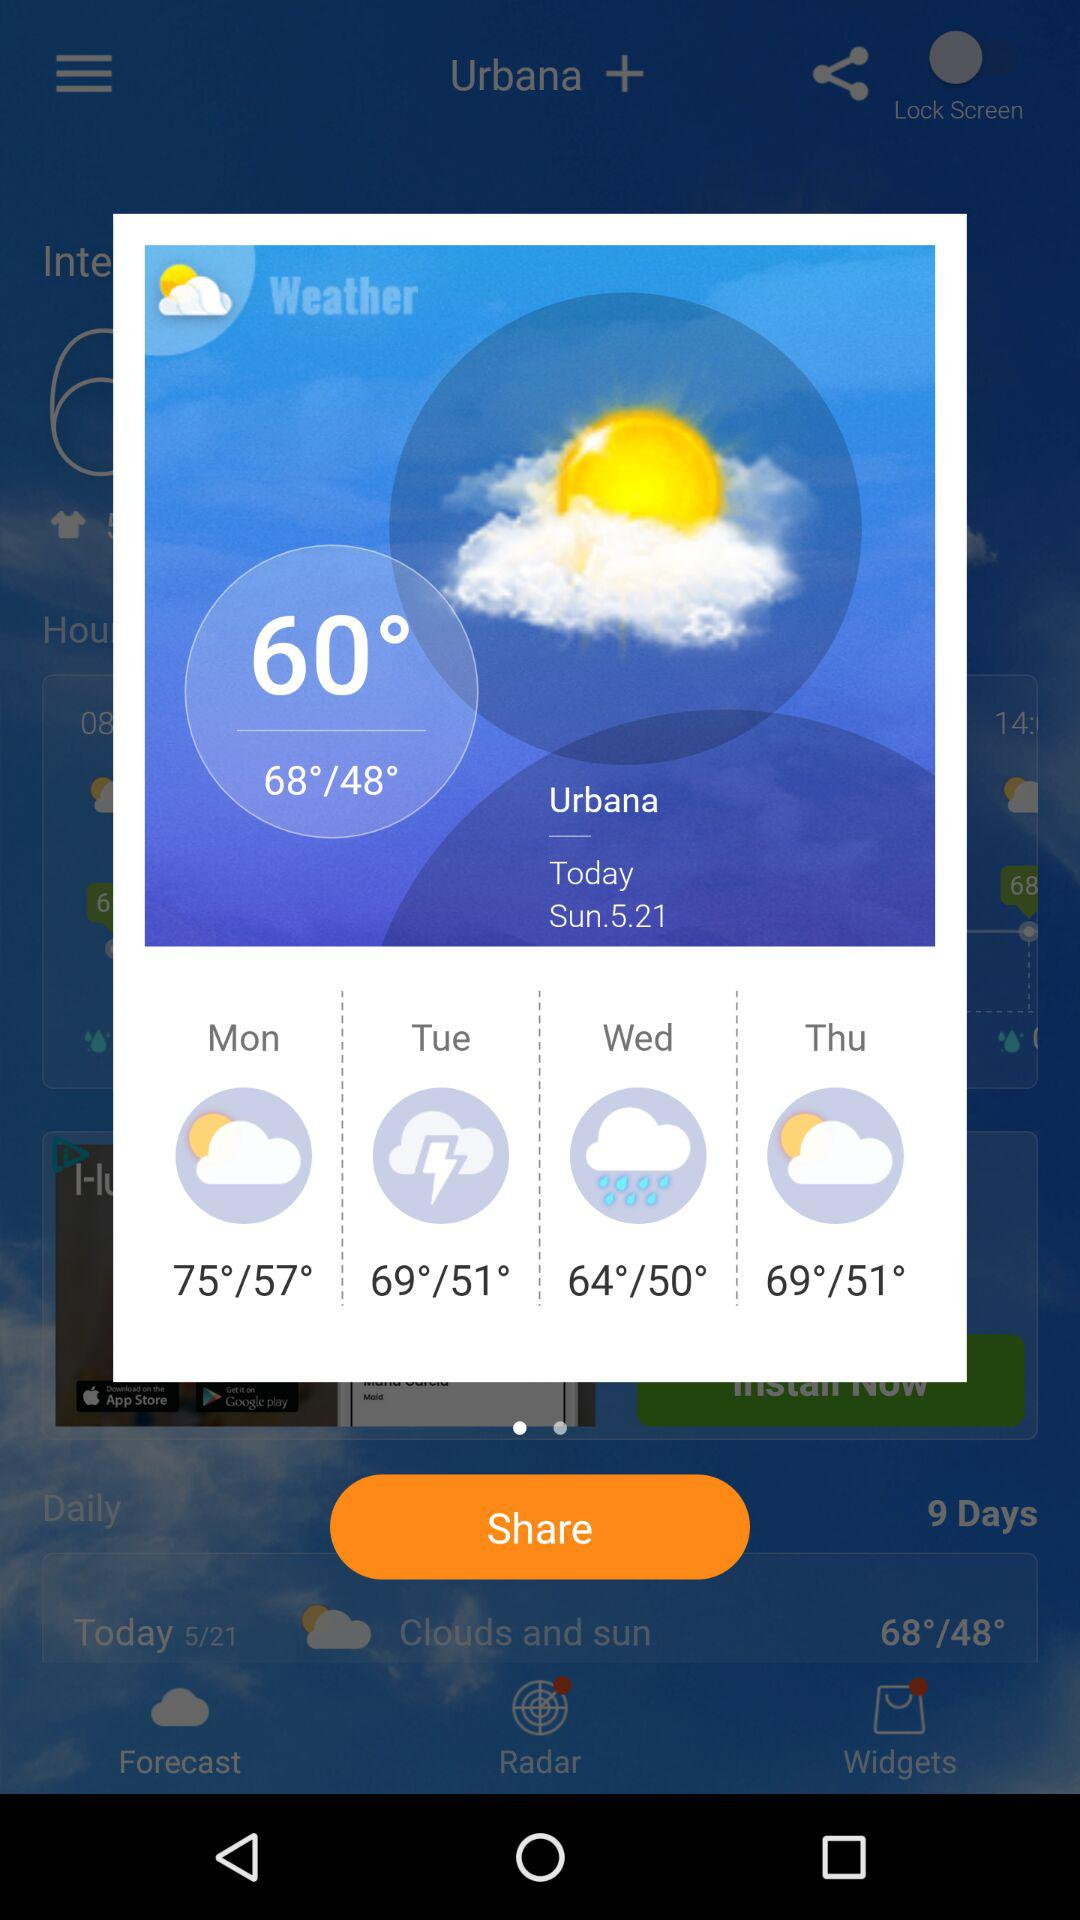What is the selected location? The selected location is Urbana. 